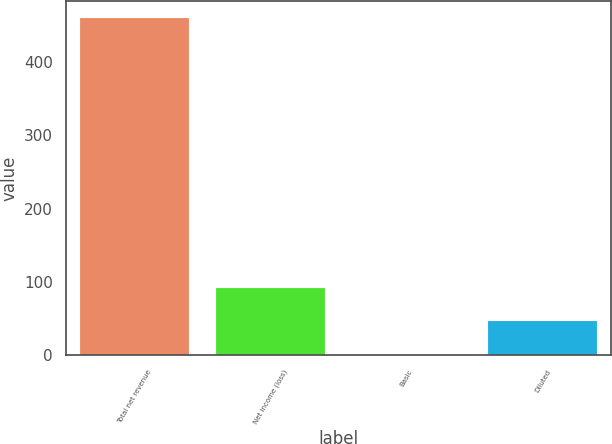<chart> <loc_0><loc_0><loc_500><loc_500><bar_chart><fcel>Total net revenue<fcel>Net income (loss)<fcel>Basic<fcel>Diluted<nl><fcel>461<fcel>92.32<fcel>0.14<fcel>46.23<nl></chart> 